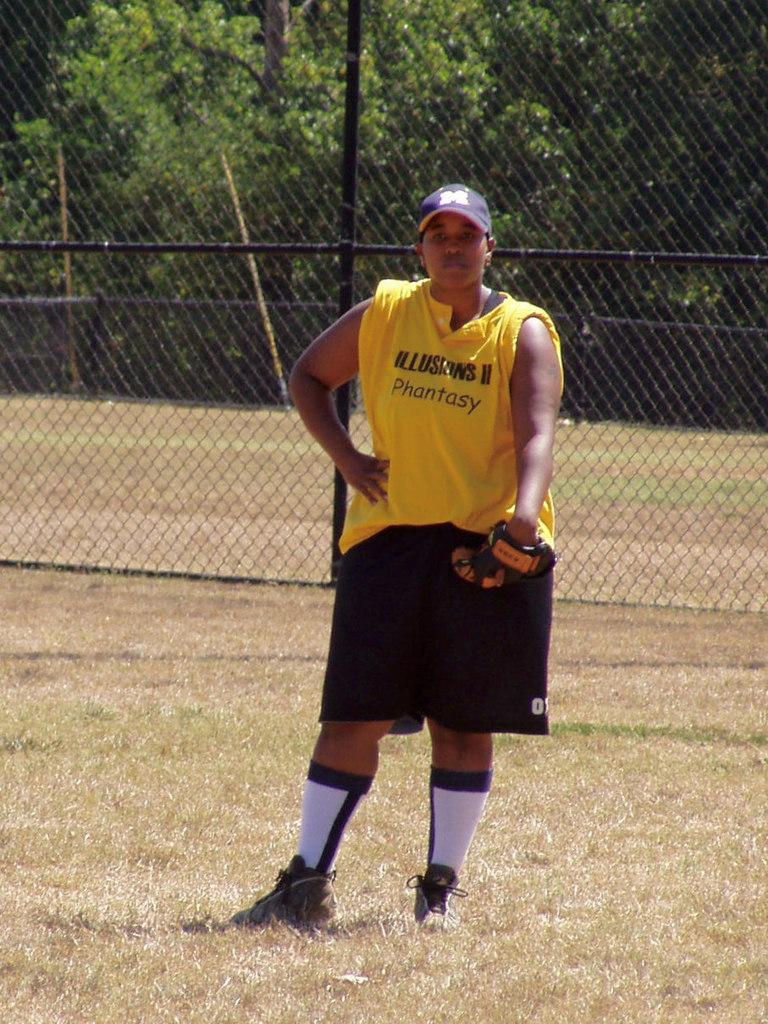<image>
Provide a brief description of the given image. A person with a yellow Illusions II Phantasy jersey on waits with their glove on in a field. 